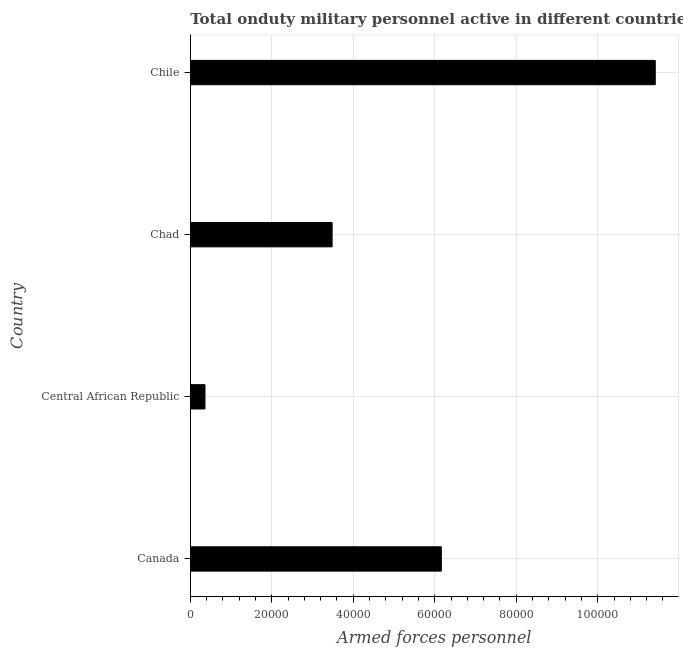Does the graph contain grids?
Give a very brief answer. Yes. What is the title of the graph?
Your answer should be compact. Total onduty military personnel active in different countries in 2003. What is the label or title of the X-axis?
Keep it short and to the point. Armed forces personnel. What is the number of armed forces personnel in Chad?
Ensure brevity in your answer.  3.48e+04. Across all countries, what is the maximum number of armed forces personnel?
Ensure brevity in your answer.  1.14e+05. Across all countries, what is the minimum number of armed forces personnel?
Provide a succinct answer. 3600. In which country was the number of armed forces personnel minimum?
Give a very brief answer. Central African Republic. What is the sum of the number of armed forces personnel?
Your answer should be very brief. 2.14e+05. What is the difference between the number of armed forces personnel in Canada and Central African Republic?
Ensure brevity in your answer.  5.80e+04. What is the average number of armed forces personnel per country?
Your answer should be very brief. 5.35e+04. What is the median number of armed forces personnel?
Your answer should be compact. 4.82e+04. In how many countries, is the number of armed forces personnel greater than 12000 ?
Provide a succinct answer. 3. What is the ratio of the number of armed forces personnel in Canada to that in Central African Republic?
Provide a succinct answer. 17.11. Is the difference between the number of armed forces personnel in Central African Republic and Chile greater than the difference between any two countries?
Offer a terse response. Yes. What is the difference between the highest and the second highest number of armed forces personnel?
Provide a succinct answer. 5.25e+04. What is the difference between the highest and the lowest number of armed forces personnel?
Ensure brevity in your answer.  1.10e+05. In how many countries, is the number of armed forces personnel greater than the average number of armed forces personnel taken over all countries?
Ensure brevity in your answer.  2. Are all the bars in the graph horizontal?
Make the answer very short. Yes. How many countries are there in the graph?
Your response must be concise. 4. What is the Armed forces personnel of Canada?
Keep it short and to the point. 6.16e+04. What is the Armed forces personnel in Central African Republic?
Provide a short and direct response. 3600. What is the Armed forces personnel in Chad?
Provide a short and direct response. 3.48e+04. What is the Armed forces personnel in Chile?
Provide a succinct answer. 1.14e+05. What is the difference between the Armed forces personnel in Canada and Central African Republic?
Offer a very short reply. 5.80e+04. What is the difference between the Armed forces personnel in Canada and Chad?
Provide a succinct answer. 2.68e+04. What is the difference between the Armed forces personnel in Canada and Chile?
Offer a very short reply. -5.25e+04. What is the difference between the Armed forces personnel in Central African Republic and Chad?
Offer a terse response. -3.12e+04. What is the difference between the Armed forces personnel in Central African Republic and Chile?
Offer a very short reply. -1.10e+05. What is the difference between the Armed forces personnel in Chad and Chile?
Your response must be concise. -7.93e+04. What is the ratio of the Armed forces personnel in Canada to that in Central African Republic?
Your response must be concise. 17.11. What is the ratio of the Armed forces personnel in Canada to that in Chad?
Keep it short and to the point. 1.77. What is the ratio of the Armed forces personnel in Canada to that in Chile?
Ensure brevity in your answer.  0.54. What is the ratio of the Armed forces personnel in Central African Republic to that in Chad?
Keep it short and to the point. 0.1. What is the ratio of the Armed forces personnel in Central African Republic to that in Chile?
Your answer should be compact. 0.03. What is the ratio of the Armed forces personnel in Chad to that in Chile?
Provide a succinct answer. 0.3. 